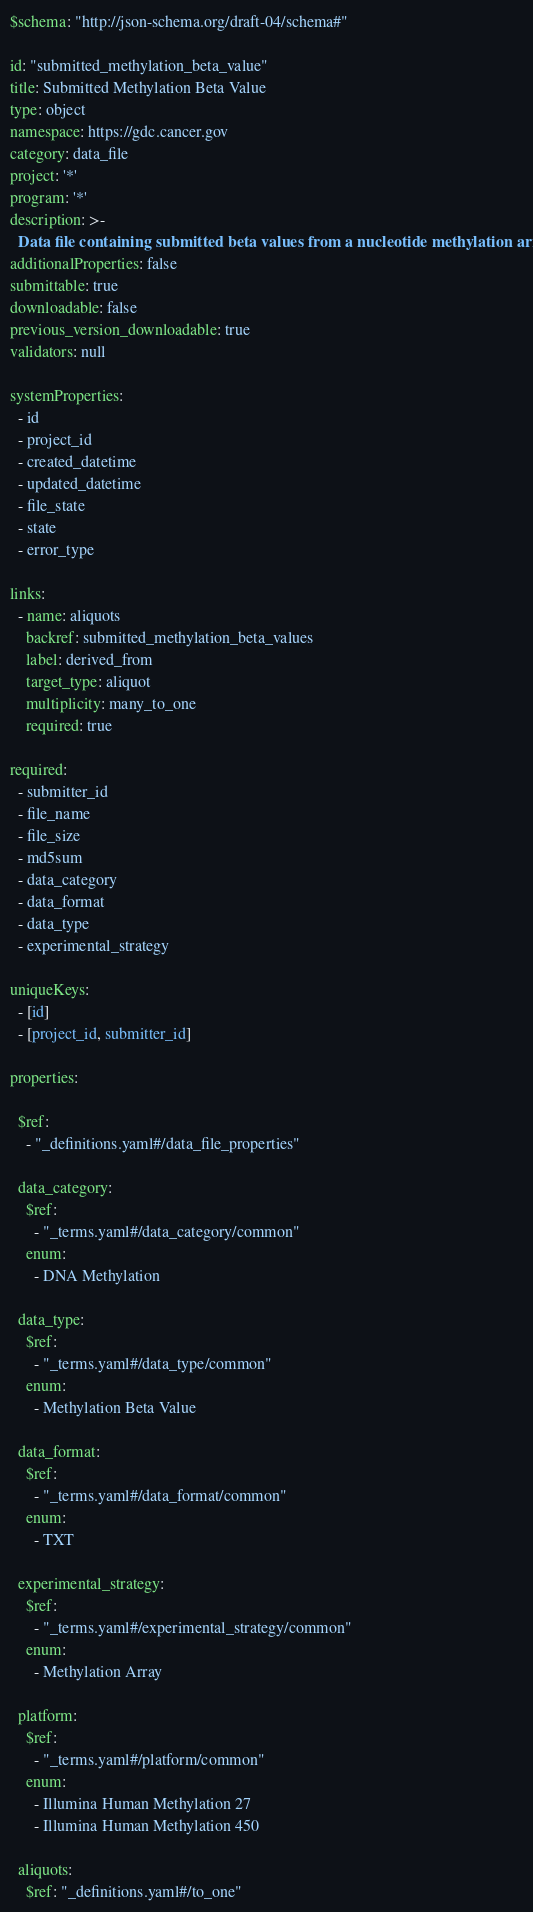<code> <loc_0><loc_0><loc_500><loc_500><_YAML_>$schema: "http://json-schema.org/draft-04/schema#"

id: "submitted_methylation_beta_value"
title: Submitted Methylation Beta Value
type: object
namespace: https://gdc.cancer.gov
category: data_file
project: '*'
program: '*'
description: >-
  Data file containing submitted beta values from a nucleotide methylation array.
additionalProperties: false
submittable: true
downloadable: false
previous_version_downloadable: true
validators: null

systemProperties:
  - id
  - project_id
  - created_datetime
  - updated_datetime
  - file_state
  - state
  - error_type

links:
  - name: aliquots
    backref: submitted_methylation_beta_values
    label: derived_from
    target_type: aliquot
    multiplicity: many_to_one
    required: true

required:
  - submitter_id
  - file_name
  - file_size
  - md5sum
  - data_category
  - data_format
  - data_type
  - experimental_strategy

uniqueKeys:
  - [id]
  - [project_id, submitter_id]

properties:

  $ref:
    - "_definitions.yaml#/data_file_properties"

  data_category:
    $ref:
      - "_terms.yaml#/data_category/common"
    enum:
      - DNA Methylation

  data_type:
    $ref:
      - "_terms.yaml#/data_type/common"
    enum:
      - Methylation Beta Value

  data_format:
    $ref:
      - "_terms.yaml#/data_format/common"
    enum:
      - TXT

  experimental_strategy:
    $ref:
      - "_terms.yaml#/experimental_strategy/common"
    enum:
      - Methylation Array

  platform:
    $ref:
      - "_terms.yaml#/platform/common"
    enum:
      - Illumina Human Methylation 27
      - Illumina Human Methylation 450

  aliquots:
    $ref: "_definitions.yaml#/to_one"
</code> 